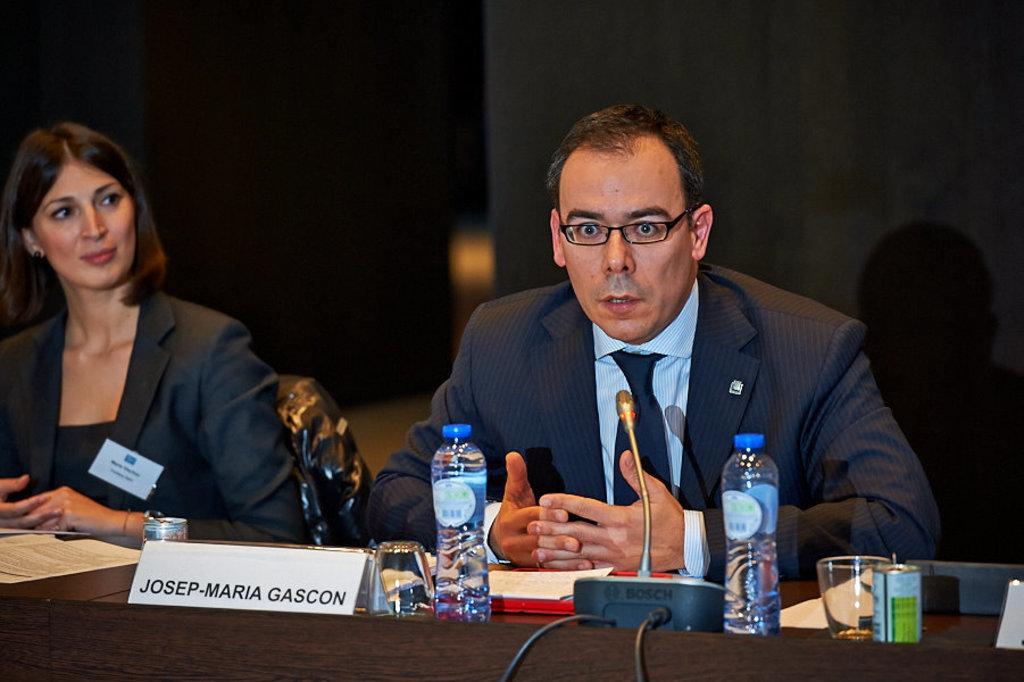Can you describe this image briefly? In this image in front there are two persons sitting on the chair. In front of them there is a table and on top of the table there are two water bottles, name board, papers, class, mile and a few other objects. On the backside there is a black wall. 